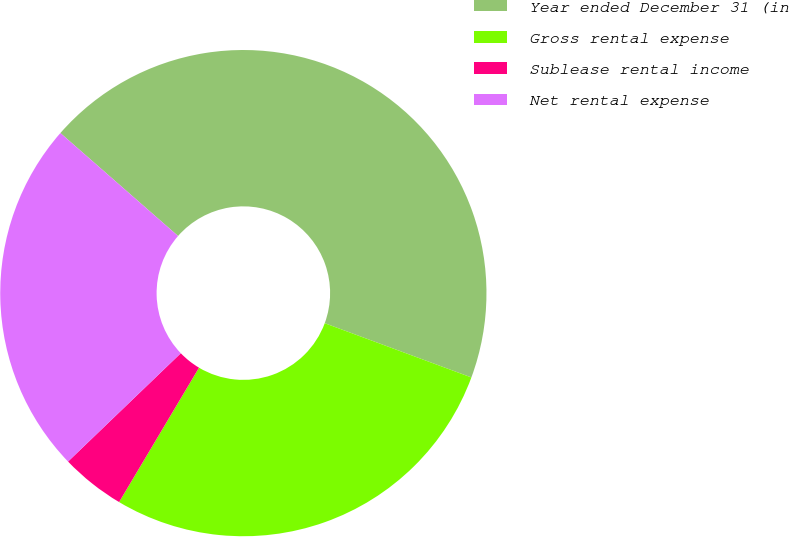<chart> <loc_0><loc_0><loc_500><loc_500><pie_chart><fcel>Year ended December 31 (in<fcel>Gross rental expense<fcel>Sublease rental income<fcel>Net rental expense<nl><fcel>44.2%<fcel>27.9%<fcel>4.28%<fcel>23.62%<nl></chart> 